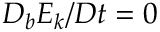<formula> <loc_0><loc_0><loc_500><loc_500>D _ { b } E _ { k } / D t = 0</formula> 